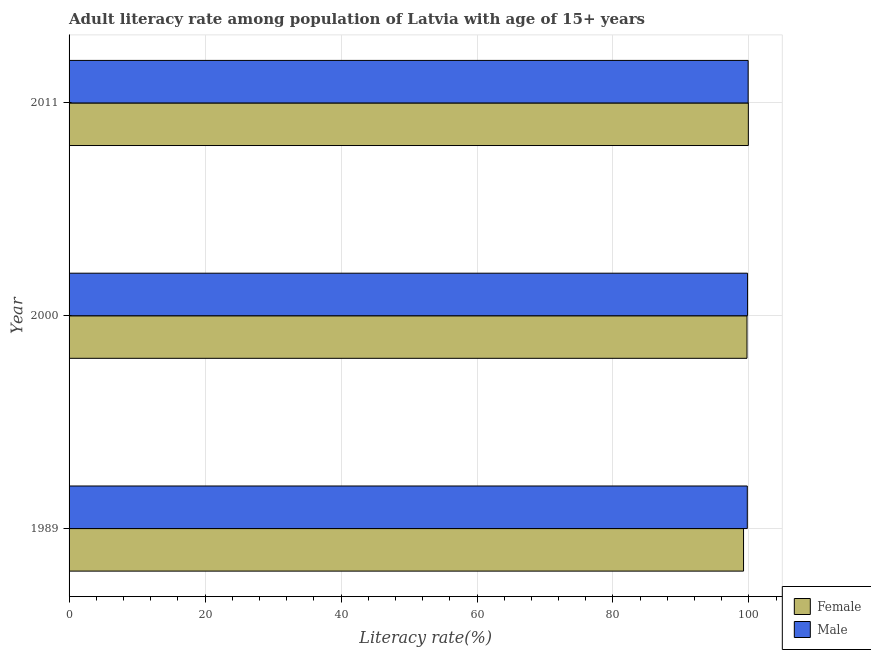What is the label of the 1st group of bars from the top?
Offer a very short reply. 2011. In how many cases, is the number of bars for a given year not equal to the number of legend labels?
Provide a short and direct response. 0. What is the male adult literacy rate in 1989?
Your answer should be very brief. 99.75. Across all years, what is the maximum male adult literacy rate?
Your answer should be compact. 99.88. Across all years, what is the minimum female adult literacy rate?
Your response must be concise. 99.2. In which year was the male adult literacy rate maximum?
Provide a succinct answer. 2011. In which year was the male adult literacy rate minimum?
Keep it short and to the point. 1989. What is the total female adult literacy rate in the graph?
Provide a short and direct response. 298.82. What is the difference between the female adult literacy rate in 1989 and that in 2000?
Offer a very short reply. -0.51. What is the difference between the male adult literacy rate in 1989 and the female adult literacy rate in 2000?
Ensure brevity in your answer.  0.04. What is the average male adult literacy rate per year?
Provide a succinct answer. 99.81. In the year 1989, what is the difference between the female adult literacy rate and male adult literacy rate?
Keep it short and to the point. -0.55. Is the male adult literacy rate in 2000 less than that in 2011?
Your answer should be very brief. Yes. Is the difference between the male adult literacy rate in 1989 and 2000 greater than the difference between the female adult literacy rate in 1989 and 2000?
Give a very brief answer. Yes. What is the difference between the highest and the second highest male adult literacy rate?
Provide a succinct answer. 0.09. What is the difference between the highest and the lowest female adult literacy rate?
Your answer should be compact. 0.71. In how many years, is the female adult literacy rate greater than the average female adult literacy rate taken over all years?
Offer a very short reply. 2. How many bars are there?
Make the answer very short. 6. What is the difference between two consecutive major ticks on the X-axis?
Your answer should be very brief. 20. Are the values on the major ticks of X-axis written in scientific E-notation?
Give a very brief answer. No. Does the graph contain any zero values?
Your answer should be very brief. No. Does the graph contain grids?
Provide a succinct answer. Yes. Where does the legend appear in the graph?
Keep it short and to the point. Bottom right. How many legend labels are there?
Provide a short and direct response. 2. What is the title of the graph?
Provide a short and direct response. Adult literacy rate among population of Latvia with age of 15+ years. What is the label or title of the X-axis?
Make the answer very short. Literacy rate(%). What is the label or title of the Y-axis?
Keep it short and to the point. Year. What is the Literacy rate(%) in Female in 1989?
Your answer should be compact. 99.2. What is the Literacy rate(%) of Male in 1989?
Give a very brief answer. 99.75. What is the Literacy rate(%) of Female in 2000?
Your response must be concise. 99.71. What is the Literacy rate(%) of Male in 2000?
Offer a terse response. 99.79. What is the Literacy rate(%) in Female in 2011?
Provide a short and direct response. 99.91. What is the Literacy rate(%) of Male in 2011?
Make the answer very short. 99.88. Across all years, what is the maximum Literacy rate(%) of Female?
Give a very brief answer. 99.91. Across all years, what is the maximum Literacy rate(%) in Male?
Ensure brevity in your answer.  99.88. Across all years, what is the minimum Literacy rate(%) in Female?
Provide a short and direct response. 99.2. Across all years, what is the minimum Literacy rate(%) of Male?
Provide a succinct answer. 99.75. What is the total Literacy rate(%) of Female in the graph?
Keep it short and to the point. 298.82. What is the total Literacy rate(%) of Male in the graph?
Offer a very short reply. 299.43. What is the difference between the Literacy rate(%) of Female in 1989 and that in 2000?
Your answer should be compact. -0.51. What is the difference between the Literacy rate(%) of Male in 1989 and that in 2000?
Your response must be concise. -0.04. What is the difference between the Literacy rate(%) in Female in 1989 and that in 2011?
Offer a very short reply. -0.71. What is the difference between the Literacy rate(%) in Male in 1989 and that in 2011?
Ensure brevity in your answer.  -0.13. What is the difference between the Literacy rate(%) in Female in 2000 and that in 2011?
Your response must be concise. -0.2. What is the difference between the Literacy rate(%) in Male in 2000 and that in 2011?
Give a very brief answer. -0.09. What is the difference between the Literacy rate(%) of Female in 1989 and the Literacy rate(%) of Male in 2000?
Give a very brief answer. -0.59. What is the difference between the Literacy rate(%) of Female in 1989 and the Literacy rate(%) of Male in 2011?
Your answer should be very brief. -0.68. What is the difference between the Literacy rate(%) of Female in 2000 and the Literacy rate(%) of Male in 2011?
Ensure brevity in your answer.  -0.17. What is the average Literacy rate(%) in Female per year?
Your response must be concise. 99.61. What is the average Literacy rate(%) of Male per year?
Offer a very short reply. 99.81. In the year 1989, what is the difference between the Literacy rate(%) in Female and Literacy rate(%) in Male?
Give a very brief answer. -0.55. In the year 2000, what is the difference between the Literacy rate(%) of Female and Literacy rate(%) of Male?
Your answer should be compact. -0.08. In the year 2011, what is the difference between the Literacy rate(%) in Female and Literacy rate(%) in Male?
Give a very brief answer. 0.03. What is the ratio of the Literacy rate(%) of Female in 1989 to that in 2000?
Your answer should be compact. 0.99. What is the ratio of the Literacy rate(%) of Male in 1989 to that in 2000?
Make the answer very short. 1. What is the ratio of the Literacy rate(%) of Male in 2000 to that in 2011?
Offer a terse response. 1. What is the difference between the highest and the second highest Literacy rate(%) in Female?
Offer a very short reply. 0.2. What is the difference between the highest and the second highest Literacy rate(%) in Male?
Your answer should be very brief. 0.09. What is the difference between the highest and the lowest Literacy rate(%) in Female?
Provide a succinct answer. 0.71. What is the difference between the highest and the lowest Literacy rate(%) in Male?
Your response must be concise. 0.13. 